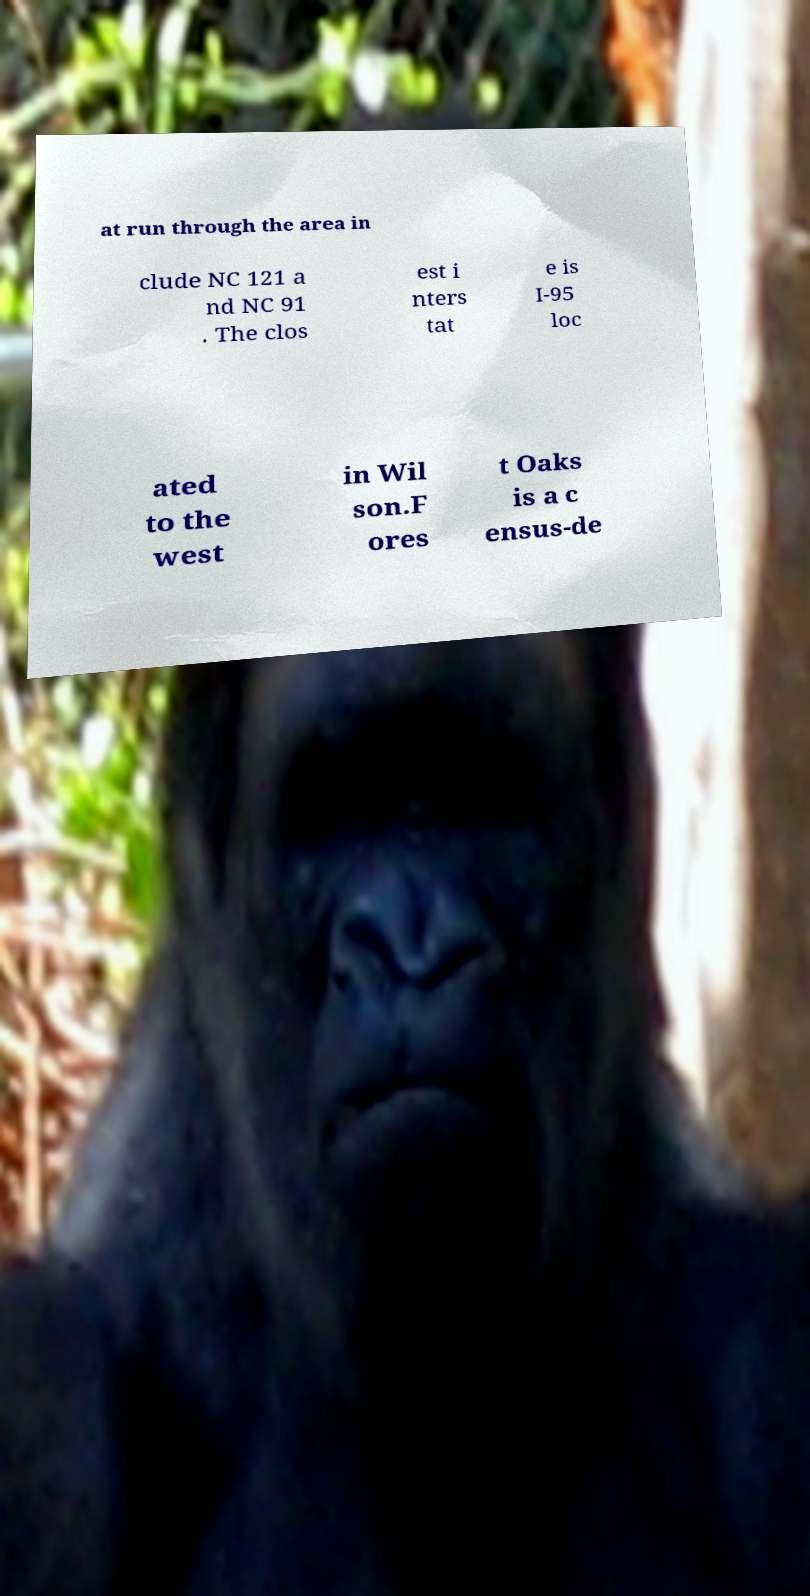Please read and relay the text visible in this image. What does it say? at run through the area in clude NC 121 a nd NC 91 . The clos est i nters tat e is I-95 loc ated to the west in Wil son.F ores t Oaks is a c ensus-de 